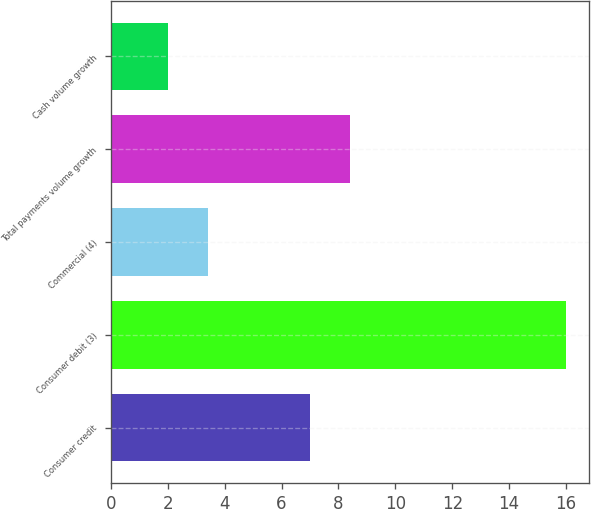Convert chart to OTSL. <chart><loc_0><loc_0><loc_500><loc_500><bar_chart><fcel>Consumer credit<fcel>Consumer debit (3)<fcel>Commercial (4)<fcel>Total payments volume growth<fcel>Cash volume growth<nl><fcel>7<fcel>16<fcel>3.4<fcel>8.4<fcel>2<nl></chart> 